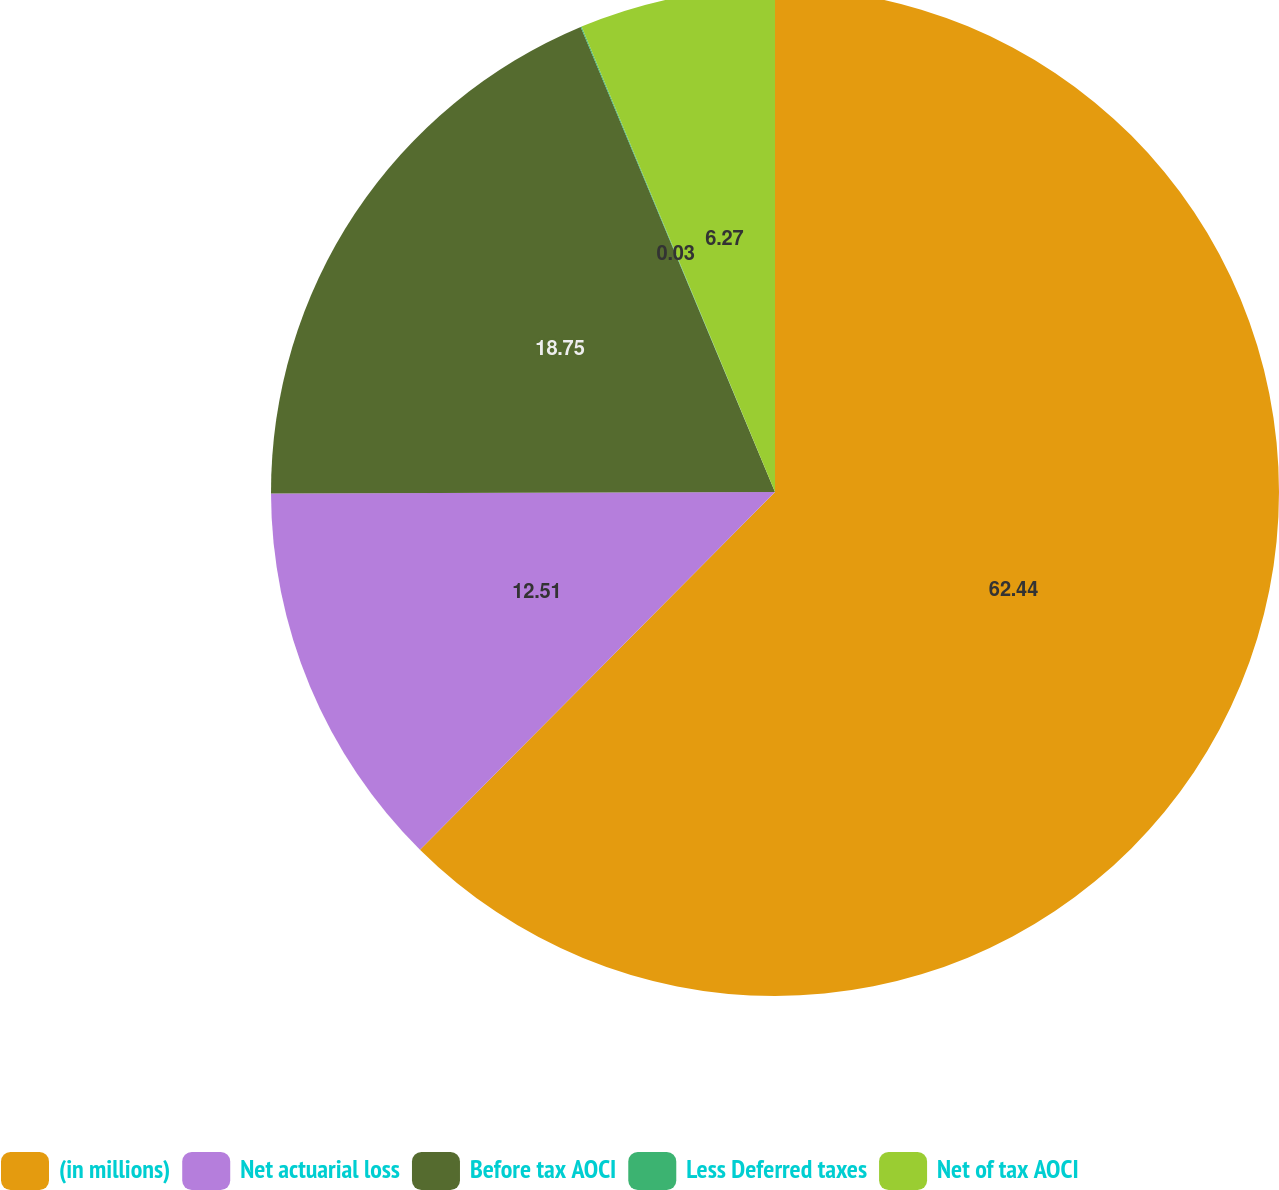<chart> <loc_0><loc_0><loc_500><loc_500><pie_chart><fcel>(in millions)<fcel>Net actuarial loss<fcel>Before tax AOCI<fcel>Less Deferred taxes<fcel>Net of tax AOCI<nl><fcel>62.44%<fcel>12.51%<fcel>18.75%<fcel>0.03%<fcel>6.27%<nl></chart> 